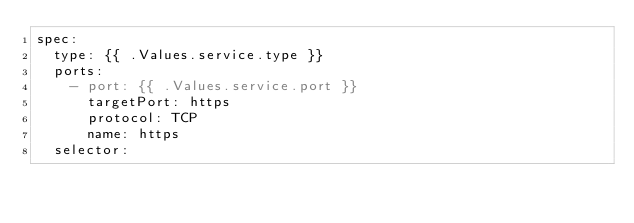Convert code to text. <code><loc_0><loc_0><loc_500><loc_500><_YAML_>spec:
  type: {{ .Values.service.type }}
  ports:
    - port: {{ .Values.service.port }}
      targetPort: https
      protocol: TCP
      name: https
  selector:</code> 